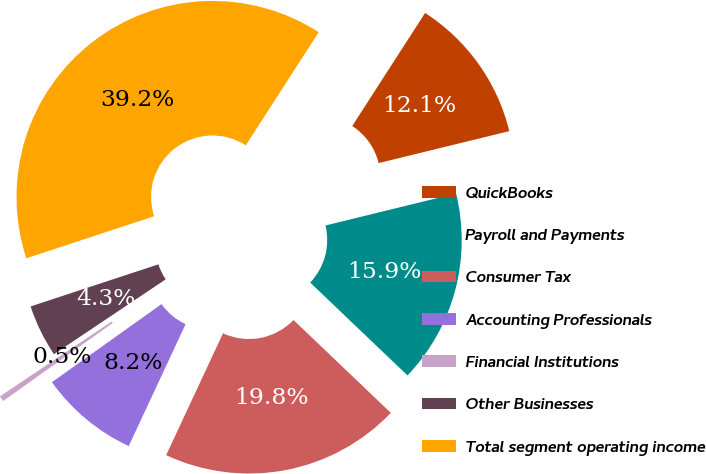Convert chart. <chart><loc_0><loc_0><loc_500><loc_500><pie_chart><fcel>QuickBooks<fcel>Payroll and Payments<fcel>Consumer Tax<fcel>Accounting Professionals<fcel>Financial Institutions<fcel>Other Businesses<fcel>Total segment operating income<nl><fcel>12.07%<fcel>15.95%<fcel>19.82%<fcel>8.2%<fcel>0.46%<fcel>4.33%<fcel>39.18%<nl></chart> 